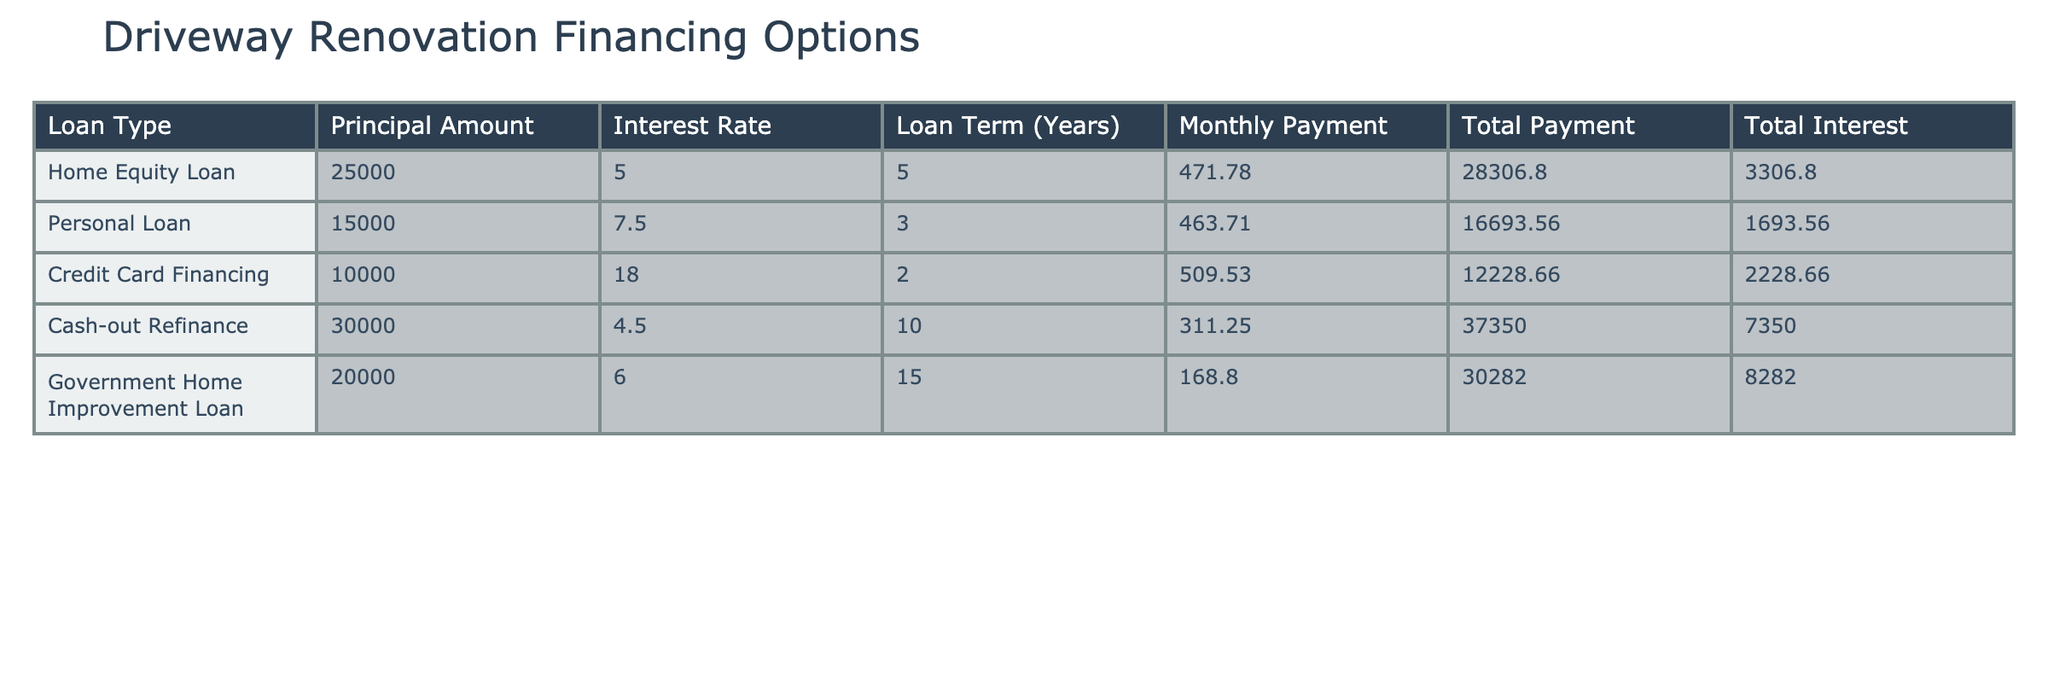What is the monthly payment for a Home Equity Loan? The table shows that the monthly payment for a Home Equity Loan is 471.78.
Answer: 471.78 Which loan option has the highest total interest paid? By examining the total interest column, the Cash-out Refinance has the highest total interest amount at 7350.00.
Answer: 7350.00 How much more is the total payment for a Cash-out Refinance compared to a Personal Loan? The total payment for Cash-out Refinance is 37350.00 and for Personal Loan, it's 16693.56. The difference is 37350.00 - 16693.56 = 20656.44.
Answer: 20656.44 Is the interest rate for a Government Home Improvement Loan less than 7%? The interest rate for the Government Home Improvement Loan is 6.0, which is less than 7%. This makes the statement true.
Answer: Yes If I took the Credit Card Financing, what would be my total payment? The table indicates that the total payment for the Credit Card Financing option is 12228.66.
Answer: 12228.66 What is the average principal amount of all the loans listed? Adding the principal amounts: 25000 + 15000 + 10000 + 30000 + 20000 = 100000. There are 5 loan types, so the average is 100000 / 5 = 20000.
Answer: 20000 Which loan type has the lowest monthly payment and what is it? Looking at the monthly payments, the Government Home Improvement Loan has the lowest payment of 168.80.
Answer: 168.80 How does the interest rate of the Credit Card Financing compare to that of the Home Equity Loan? The interest rate for Credit Card Financing is 18.0%, which is significantly higher than the Home Equity Loan's rate of 5.0%. This indicates a larger cost of borrowing for the Credit Card Financing.
Answer: Higher If I wanted to minimize total interest paid, which loan option should I choose? Comparing the total interest amounts across all options, the Home Equity Loan has the lowest total interest cost of 3306.80. Therefore, the Home Equity Loan is the optimal choice for minimizing total interest.
Answer: Home Equity Loan 